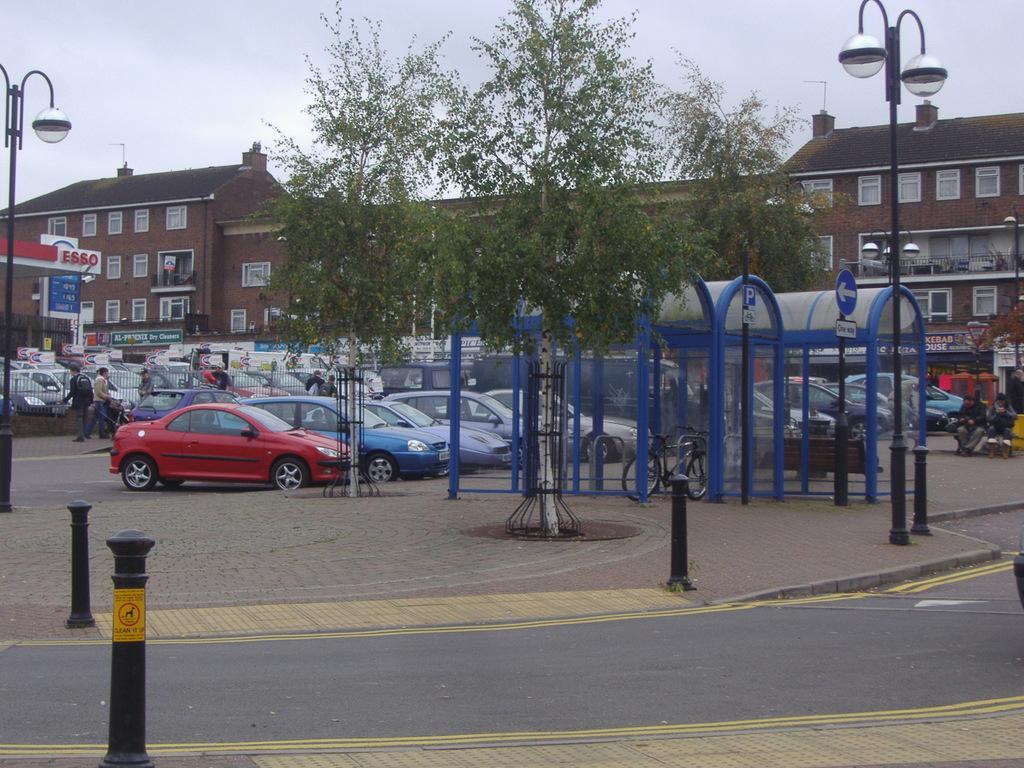In one or two sentences, can you explain what this image depicts? In this image there are so many cars on the road, beside that there are people standing also there are some boots, tree and street light poles and buildings. 